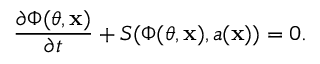Convert formula to latex. <formula><loc_0><loc_0><loc_500><loc_500>\frac { \partial \Phi ( \theta , x ) } { \partial t } + S ( \Phi ( \theta , x ) , a ( x ) ) = 0 .</formula> 